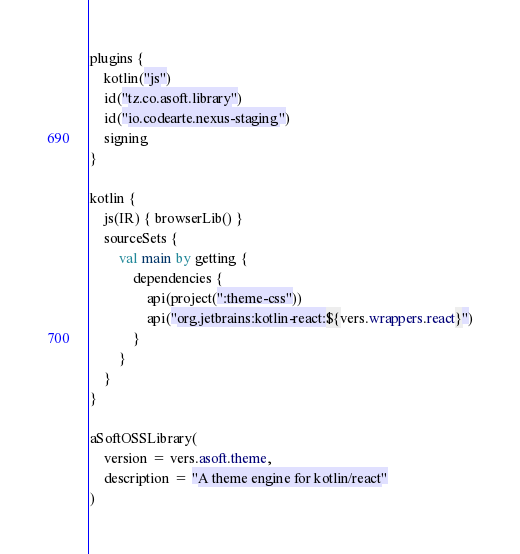Convert code to text. <code><loc_0><loc_0><loc_500><loc_500><_Kotlin_>plugins {
    kotlin("js")
    id("tz.co.asoft.library")
    id("io.codearte.nexus-staging")
    signing
}

kotlin {
    js(IR) { browserLib() }
    sourceSets {
        val main by getting {
            dependencies {
                api(project(":theme-css"))
                api("org.jetbrains:kotlin-react:${vers.wrappers.react}")
            }
        }
    }
}

aSoftOSSLibrary(
    version = vers.asoft.theme,
    description = "A theme engine for kotlin/react"
)
</code> 